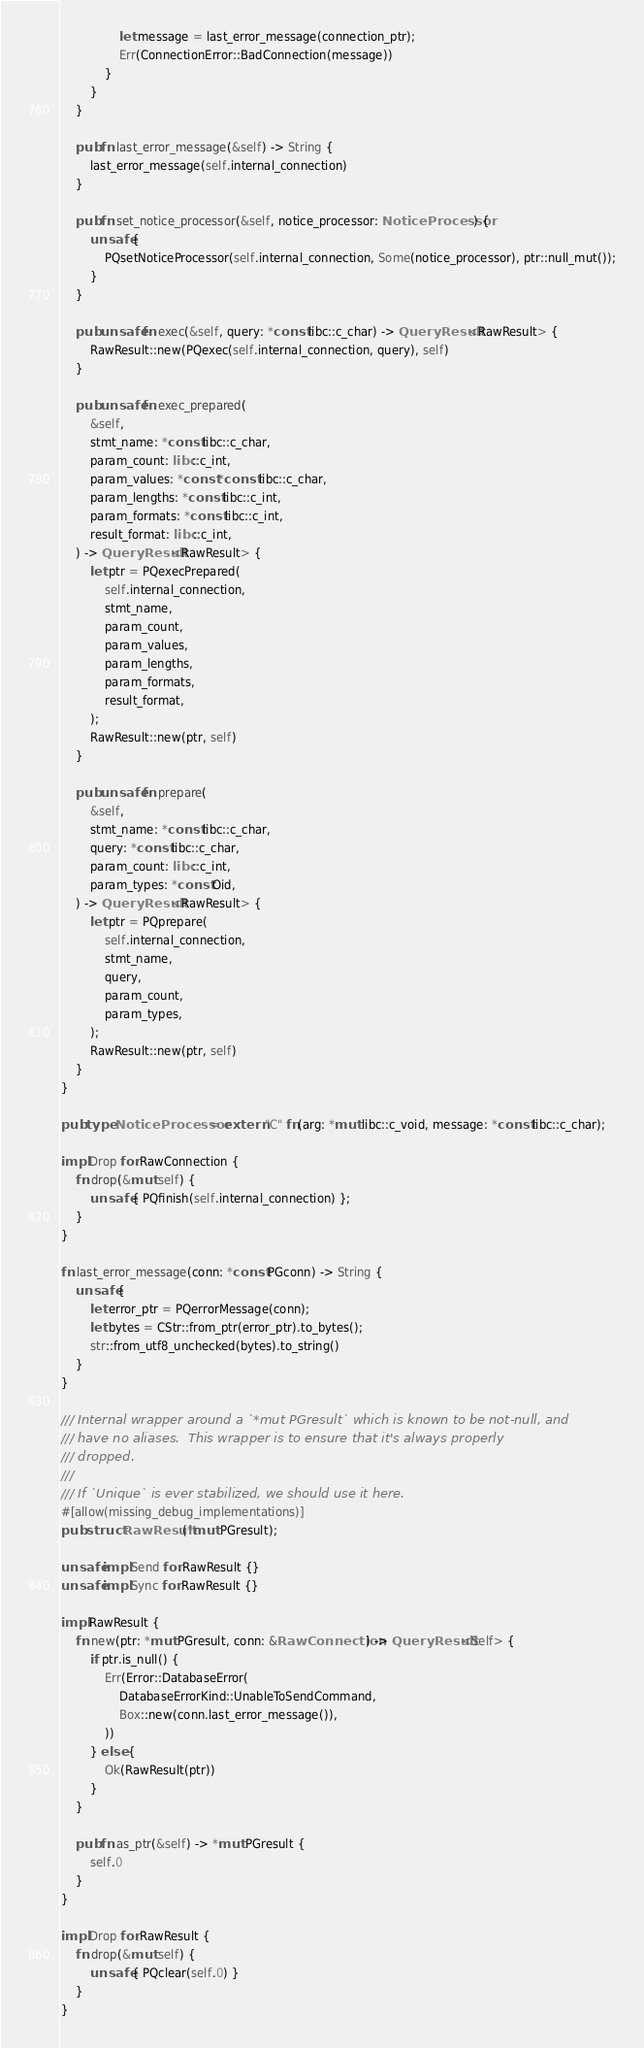<code> <loc_0><loc_0><loc_500><loc_500><_Rust_>                let message = last_error_message(connection_ptr);
                Err(ConnectionError::BadConnection(message))
            }
        }
    }

    pub fn last_error_message(&self) -> String {
        last_error_message(self.internal_connection)
    }

    pub fn set_notice_processor(&self, notice_processor: NoticeProcessor) {
        unsafe {
            PQsetNoticeProcessor(self.internal_connection, Some(notice_processor), ptr::null_mut());
        }
    }

    pub unsafe fn exec(&self, query: *const libc::c_char) -> QueryResult<RawResult> {
        RawResult::new(PQexec(self.internal_connection, query), self)
    }

    pub unsafe fn exec_prepared(
        &self,
        stmt_name: *const libc::c_char,
        param_count: libc::c_int,
        param_values: *const *const libc::c_char,
        param_lengths: *const libc::c_int,
        param_formats: *const libc::c_int,
        result_format: libc::c_int,
    ) -> QueryResult<RawResult> {
        let ptr = PQexecPrepared(
            self.internal_connection,
            stmt_name,
            param_count,
            param_values,
            param_lengths,
            param_formats,
            result_format,
        );
        RawResult::new(ptr, self)
    }

    pub unsafe fn prepare(
        &self,
        stmt_name: *const libc::c_char,
        query: *const libc::c_char,
        param_count: libc::c_int,
        param_types: *const Oid,
    ) -> QueryResult<RawResult> {
        let ptr = PQprepare(
            self.internal_connection,
            stmt_name,
            query,
            param_count,
            param_types,
        );
        RawResult::new(ptr, self)
    }
}

pub type NoticeProcessor = extern "C" fn(arg: *mut libc::c_void, message: *const libc::c_char);

impl Drop for RawConnection {
    fn drop(&mut self) {
        unsafe { PQfinish(self.internal_connection) };
    }
}

fn last_error_message(conn: *const PGconn) -> String {
    unsafe {
        let error_ptr = PQerrorMessage(conn);
        let bytes = CStr::from_ptr(error_ptr).to_bytes();
        str::from_utf8_unchecked(bytes).to_string()
    }
}

/// Internal wrapper around a `*mut PGresult` which is known to be not-null, and
/// have no aliases.  This wrapper is to ensure that it's always properly
/// dropped.
///
/// If `Unique` is ever stabilized, we should use it here.
#[allow(missing_debug_implementations)]
pub struct RawResult(*mut PGresult);

unsafe impl Send for RawResult {}
unsafe impl Sync for RawResult {}

impl RawResult {
    fn new(ptr: *mut PGresult, conn: &RawConnection) -> QueryResult<Self> {
        if ptr.is_null() {
            Err(Error::DatabaseError(
                DatabaseErrorKind::UnableToSendCommand,
                Box::new(conn.last_error_message()),
            ))
        } else {
            Ok(RawResult(ptr))
        }
    }

    pub fn as_ptr(&self) -> *mut PGresult {
        self.0
    }
}

impl Drop for RawResult {
    fn drop(&mut self) {
        unsafe { PQclear(self.0) }
    }
}
</code> 